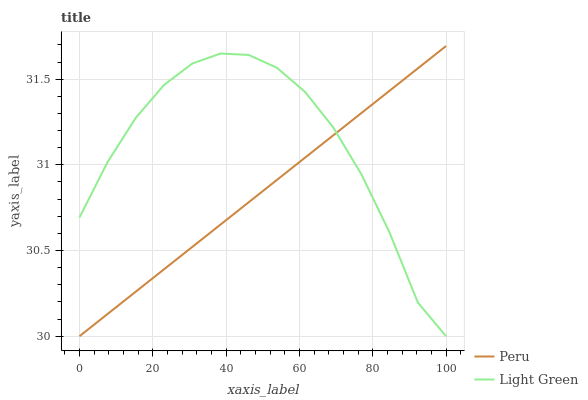Does Peru have the minimum area under the curve?
Answer yes or no. Yes. Does Light Green have the maximum area under the curve?
Answer yes or no. Yes. Does Peru have the maximum area under the curve?
Answer yes or no. No. Is Peru the smoothest?
Answer yes or no. Yes. Is Light Green the roughest?
Answer yes or no. Yes. Is Peru the roughest?
Answer yes or no. No. Does Light Green have the lowest value?
Answer yes or no. Yes. Does Peru have the highest value?
Answer yes or no. Yes. Does Peru intersect Light Green?
Answer yes or no. Yes. Is Peru less than Light Green?
Answer yes or no. No. Is Peru greater than Light Green?
Answer yes or no. No. 